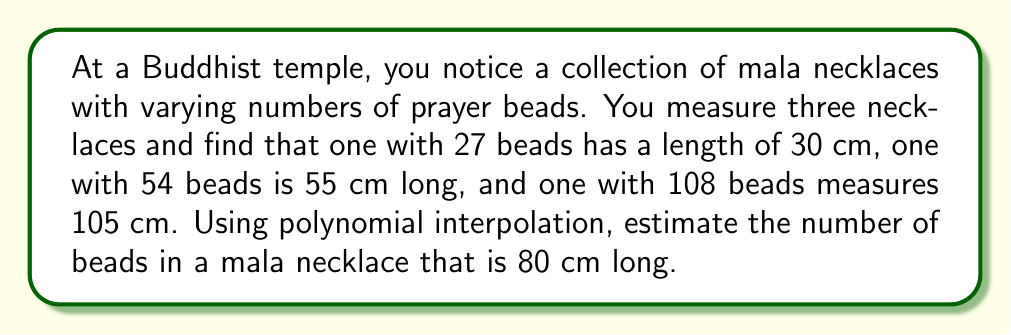What is the answer to this math problem? To solve this problem, we'll use Lagrange polynomial interpolation. Let's follow these steps:

1) Let $x$ represent the number of beads and $y$ represent the length in cm. We have three data points:
   $(x_0, y_0) = (27, 30)$, $(x_1, y_1) = (54, 55)$, $(x_2, y_2) = (108, 105)$

2) The Lagrange interpolation polynomial is given by:
   $$L(x) = y_0\frac{(x-x_1)(x-x_2)}{(x_0-x_1)(x_0-x_2)} + y_1\frac{(x-x_0)(x-x_2)}{(x_1-x_0)(x_1-x_2)} + y_2\frac{(x-x_0)(x-x_1)}{(x_2-x_0)(x_2-x_1)}$$

3) Substituting our values:
   $$L(x) = 30\frac{(x-54)(x-108)}{(27-54)(27-108)} + 55\frac{(x-27)(x-108)}{(54-27)(54-108)} + 105\frac{(x-27)(x-54)}{(108-27)(108-54)}$$

4) Simplifying:
   $$L(x) = 30\frac{(x-54)(x-108)}{(-27)(-81)} + 55\frac{(x-27)(x-108)}{(27)(-54)} + 105\frac{(x-27)(x-54)}{(81)(54)}$$
   $$L(x) = \frac{30(x^2-162x+5832)}{2187} - \frac{55(x^2-135x+2916)}{1458} + \frac{105(x^2-81x+1458)}{4374}$$

5) We want to find $x$ when $L(x) = 80$. This gives us the equation:
   $$80 = \frac{30(x^2-162x+5832)}{2187} - \frac{55(x^2-135x+2916)}{1458} + \frac{105(x^2-81x+1458)}{4374}$$

6) Solving this equation numerically (as it's a complex quadratic equation), we get:
   $x \approx 81.6$

7) Since the number of beads must be an integer, we round to the nearest whole number.
Answer: The estimated number of beads in an 80 cm long mala necklace is approximately 82 beads. 